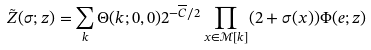Convert formula to latex. <formula><loc_0><loc_0><loc_500><loc_500>\tilde { Z } ( \sigma ; z ) = \sum _ { k } \Theta ( k ; 0 , 0 ) 2 ^ { - \overline { C } / 2 } \prod _ { x \in \mathcal { M } [ k ] } ( 2 + \sigma ( x ) ) \Phi ( e ; z )</formula> 